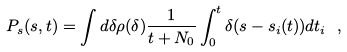<formula> <loc_0><loc_0><loc_500><loc_500>P _ { s } ( s , t ) = \int d \delta \rho ( \delta ) \frac { 1 } { t + N _ { 0 } } \int _ { 0 } ^ { t } \delta ( s - s _ { i } ( t ) ) d t _ { i } \ ,</formula> 